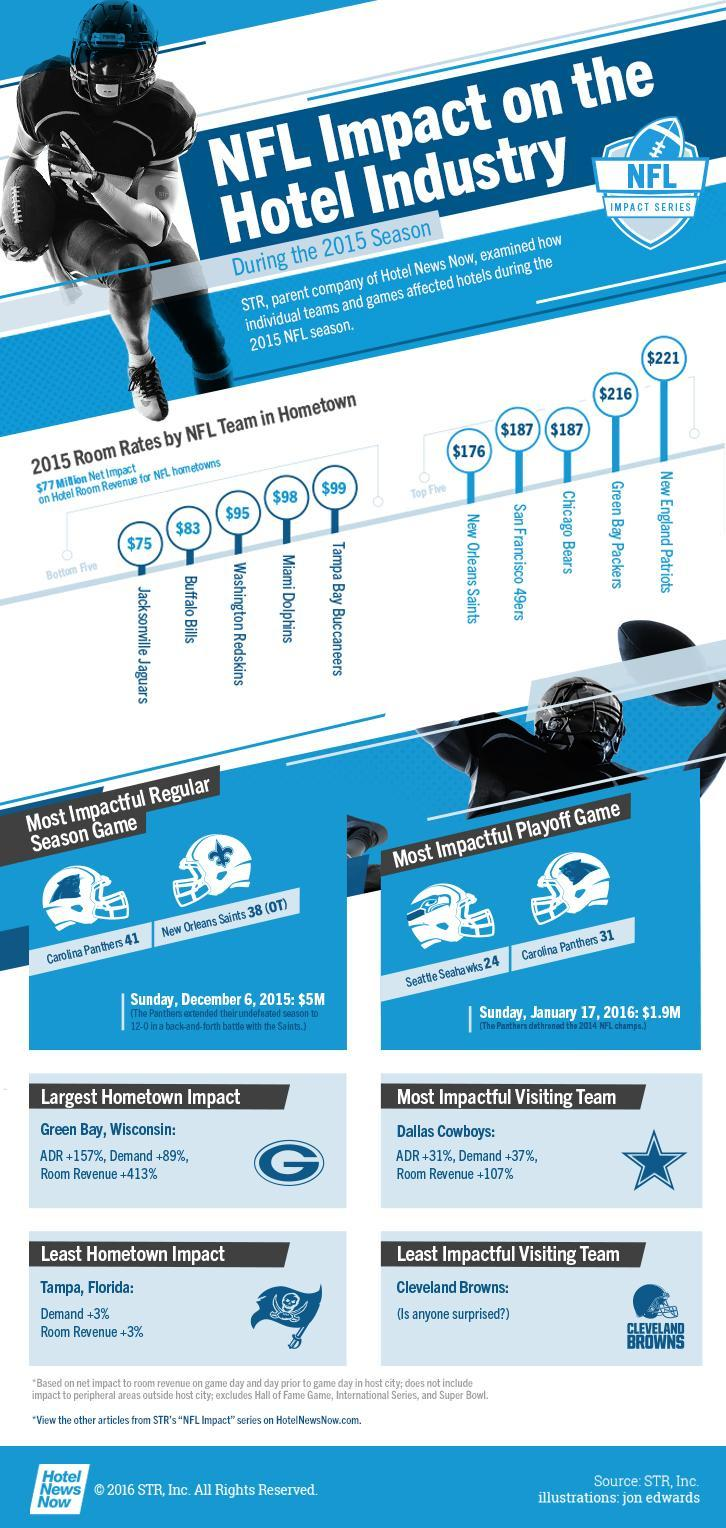Which NFL Team came in Fourth among the top 5 teams on hotel room revenue?
Answer the question with a short phrase. San Francisco 49ers Which NFL Team came in fourth among the bottom 5 teams on hotel room revenue? Miami Dolphins Which NFL Team came in third among the top 5 teams on hotel room revenue? Chicago Bears Which NFL Team came in third among the bottom 5 teams on hotel room revenue? Washington Redskins What was the revenue on the most impactful Regular season game? $5M What was the revenue on the most impactful playoff game? $1.9M 